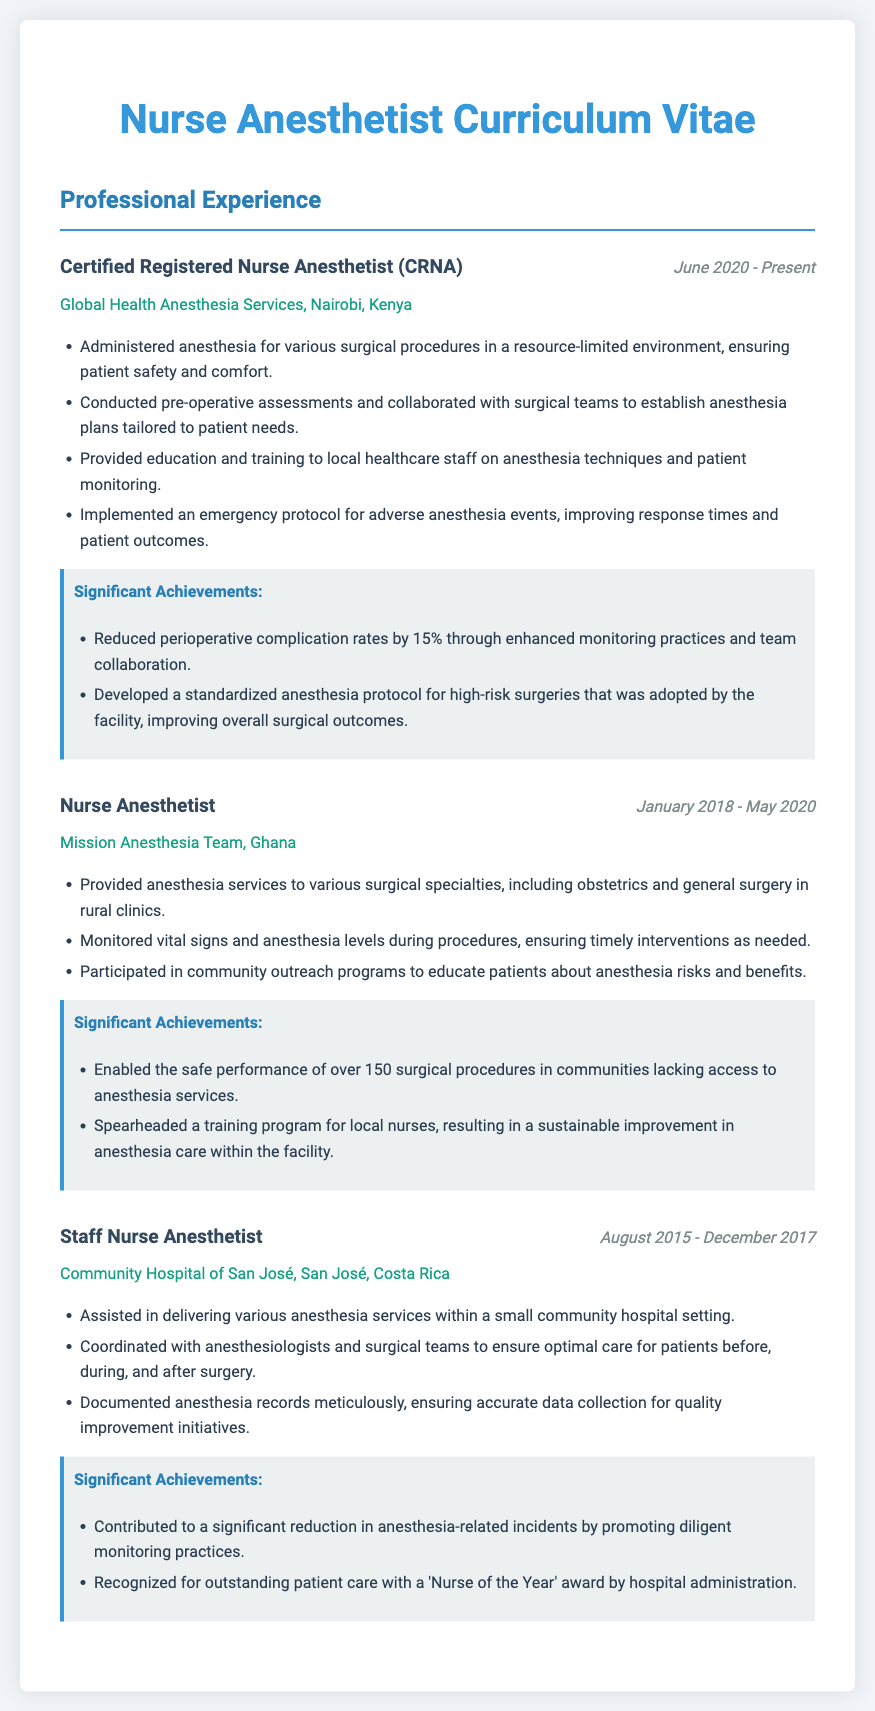what is the title of the current position? The current position is listed as Certified Registered Nurse Anesthetist (CRNA).
Answer: Certified Registered Nurse Anesthetist (CRNA) where does the current position take place? The location of the current position is provided, which is Global Health Anesthesia Services, Nairobi, Kenya.
Answer: Global Health Anesthesia Services, Nairobi, Kenya what is the period of employment for the previous position? The dates when the previous position was held can be found, which are January 2018 to May 2020.
Answer: January 2018 - May 2020 how many surgical procedures were safely performed in Ghana? The document mentions the number of surgeries performed in Ghana, which is over 150.
Answer: over 150 what significant achievement is related to anesthesia for high-risk surgeries? A standardized anesthesia protocol was developed for high-risk surgeries, which was adopted by the facility.
Answer: standardized anesthesia protocol which award was received at Community Hospital of San José? The accomplishment related to recognition at the Community Hospital of San José is the 'Nurse of the Year' award.
Answer: Nurse of the Year which location had the earliest employment date? The first job listed in the document is at Community Hospital of San José, which had employment starting in August 2015.
Answer: Community Hospital of San José what type of education was provided in Nairobi? The document indicates that education and training related to anesthesia techniques were provided to local healthcare staff.
Answer: education and training on anesthesia techniques 